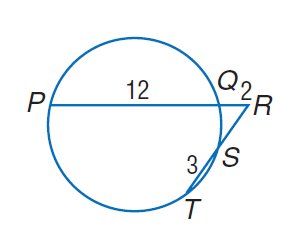Question: Find R S if P Q = 12, Q R = 2, and T S = 3.
Choices:
A. 2
B. 3
C. 4
D. 12
Answer with the letter. Answer: C 